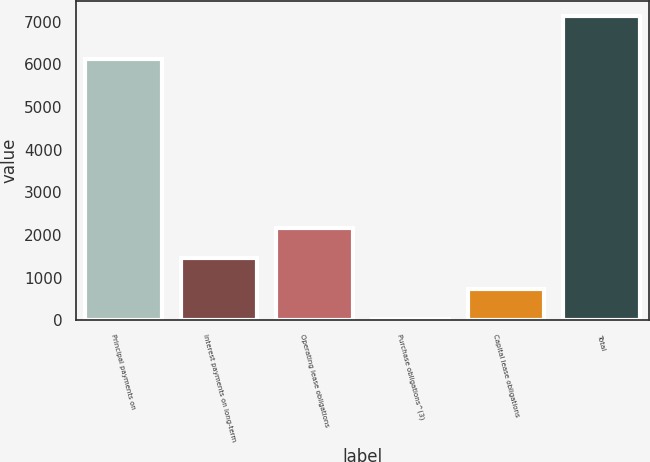Convert chart. <chart><loc_0><loc_0><loc_500><loc_500><bar_chart><fcel>Principal payments on<fcel>Interest payments on long-term<fcel>Operating lease obligations<fcel>Purchase obligations^(3)<fcel>Capital lease obligations<fcel>Total<nl><fcel>6119<fcel>1452.2<fcel>2162.8<fcel>31<fcel>741.6<fcel>7137<nl></chart> 